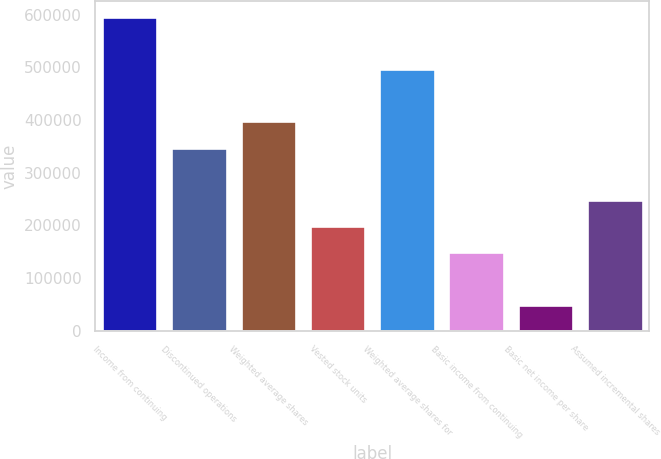Convert chart. <chart><loc_0><loc_0><loc_500><loc_500><bar_chart><fcel>Income from continuing<fcel>Discontinued operations<fcel>Weighted average shares<fcel>Vested stock units<fcel>Weighted average shares for<fcel>Basic income from continuing<fcel>Basic net income per share<fcel>Assumed incremental shares<nl><fcel>595820<fcel>347563<fcel>397214<fcel>198608<fcel>496517<fcel>148957<fcel>49653.9<fcel>248260<nl></chart> 